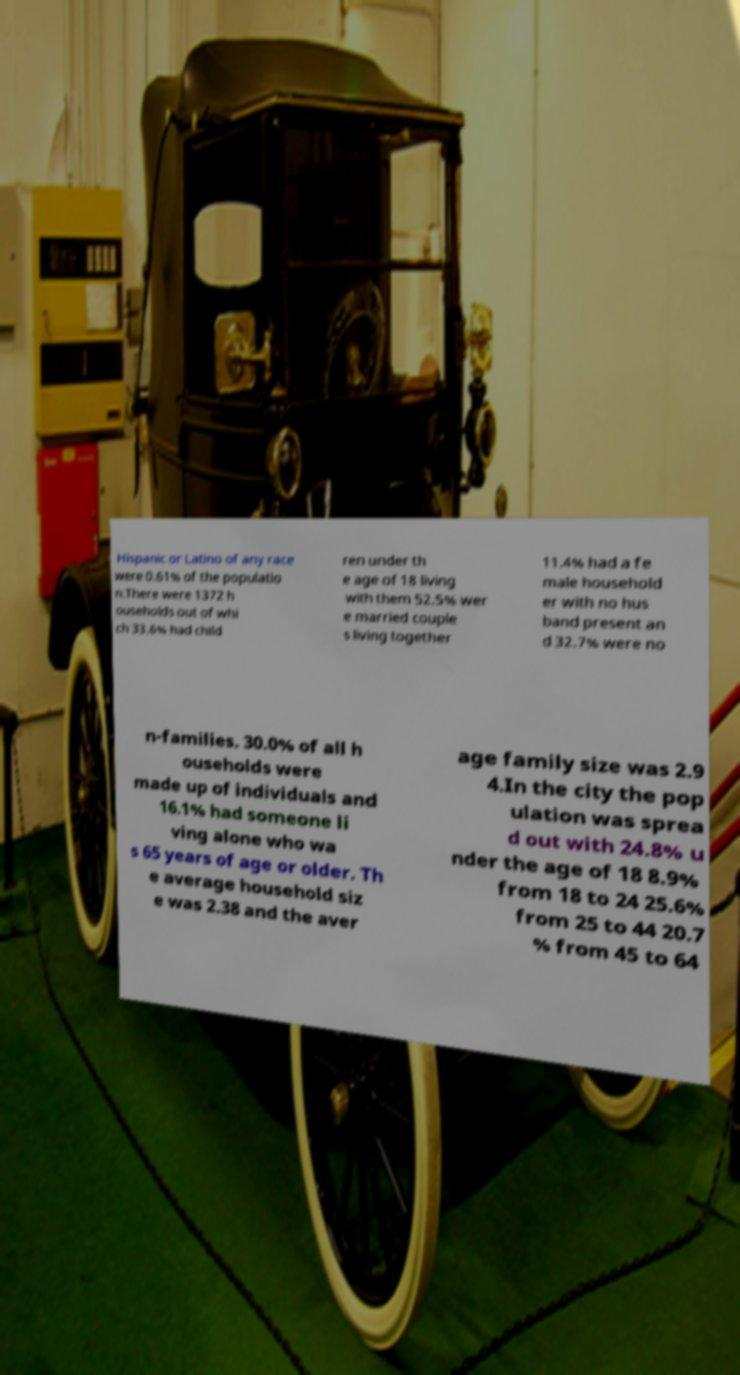I need the written content from this picture converted into text. Can you do that? Hispanic or Latino of any race were 0.61% of the populatio n.There were 1372 h ouseholds out of whi ch 33.6% had child ren under th e age of 18 living with them 52.5% wer e married couple s living together 11.4% had a fe male household er with no hus band present an d 32.7% were no n-families. 30.0% of all h ouseholds were made up of individuals and 16.1% had someone li ving alone who wa s 65 years of age or older. Th e average household siz e was 2.38 and the aver age family size was 2.9 4.In the city the pop ulation was sprea d out with 24.8% u nder the age of 18 8.9% from 18 to 24 25.6% from 25 to 44 20.7 % from 45 to 64 